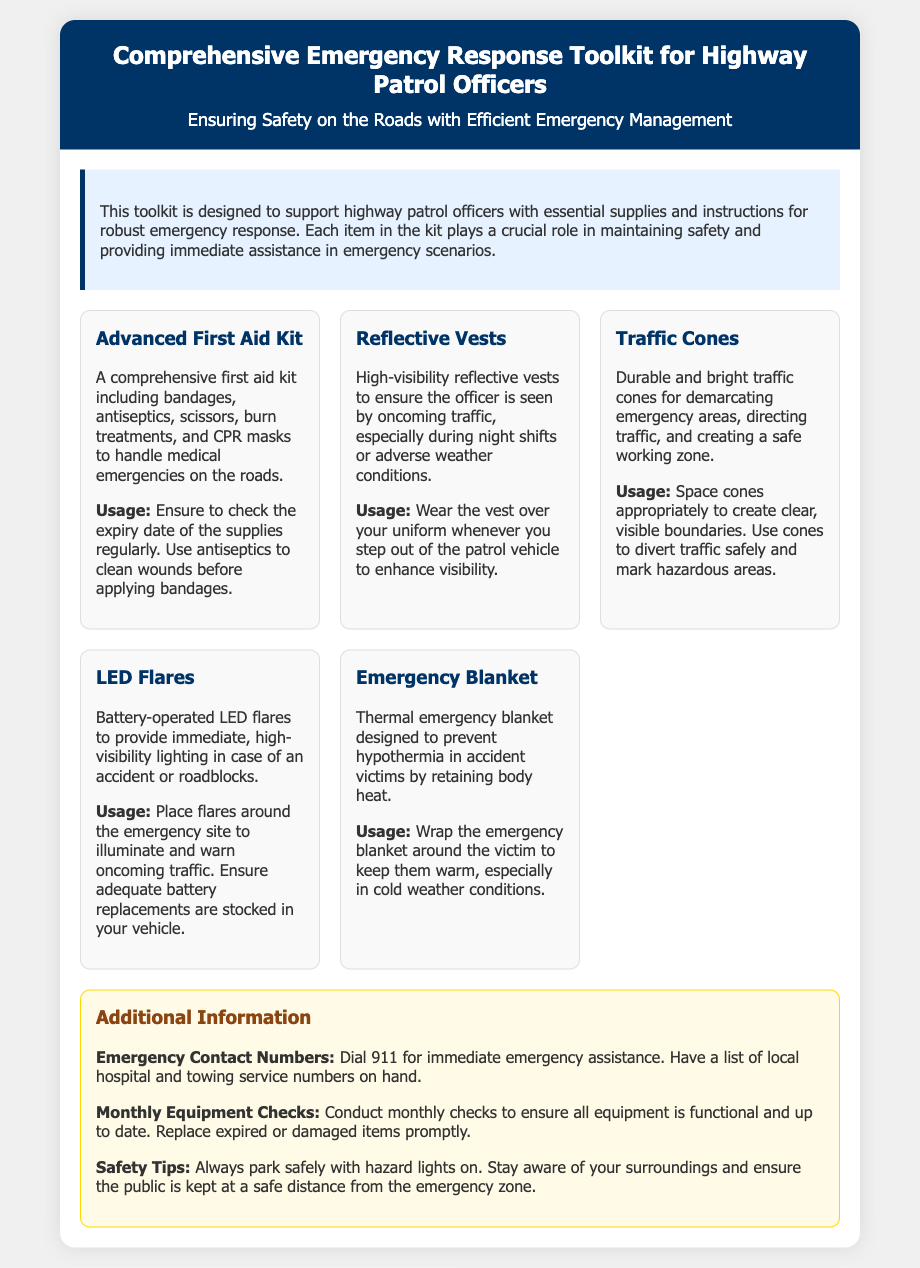What is the title of the toolkit? The title of the toolkit is located in the header of the document.
Answer: Comprehensive Emergency Response Toolkit for Highway Patrol Officers How many items are listed in the toolkit? The number of items can be counted in the toolkit items section.
Answer: Five What is included in the Advanced First Aid Kit? The contents of the Advanced First Aid Kit are described in the item details.
Answer: Bandages, antiseptics, scissors, burn treatments, CPR masks What should be worn to enhance visibility? This information is indicated in the details about the reflective vests.
Answer: Reflective vests What is the purpose of traffic cones? The use of traffic cones is clarified in the toolkit items.
Answer: Demarcating emergency areas, directing traffic, creating a safe working zone What additional safety tip is mentioned? A specific safety tip is provided in the additional information section.
Answer: Always park safely with hazard lights on How should a victim be kept warm? The method to keep the victim warm is mentioned in the emergency blanket details.
Answer: Wrap the emergency blanket around the victim What emergency contact number should be dialed? This important information is found in the additional information section.
Answer: 911 